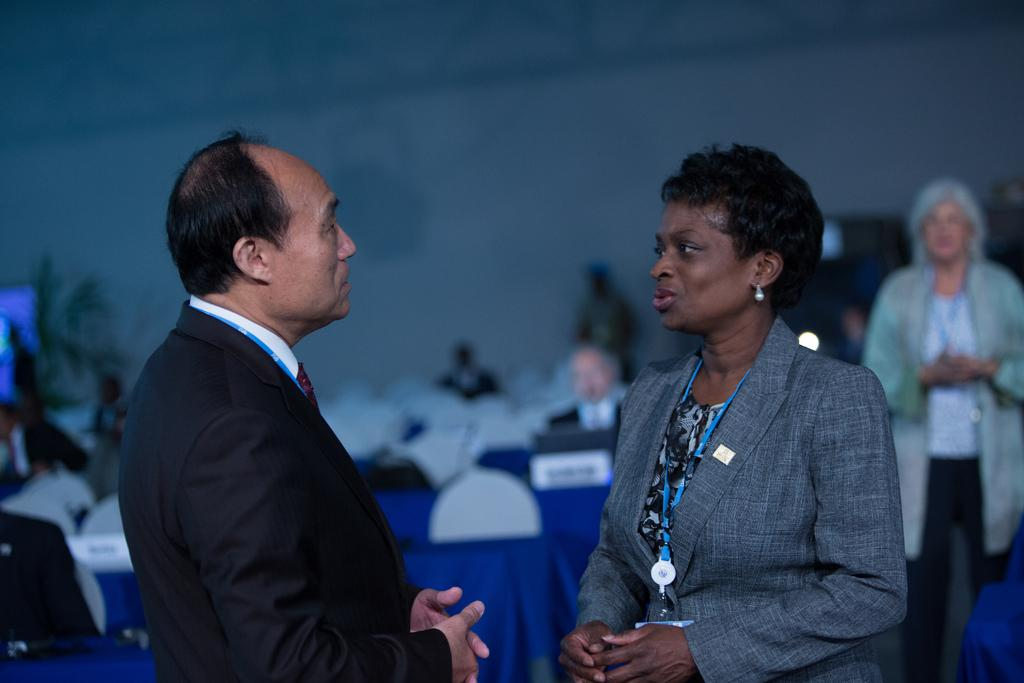What are the two persons in the foreground doing? The two persons in the foreground are talking to each other. What can be seen in the background of the image? There are chairs and other persons visible in the background, as well as a wall. Can you see the grandfather pushing sand in the image? There is no grandfather or sand present in the image. 